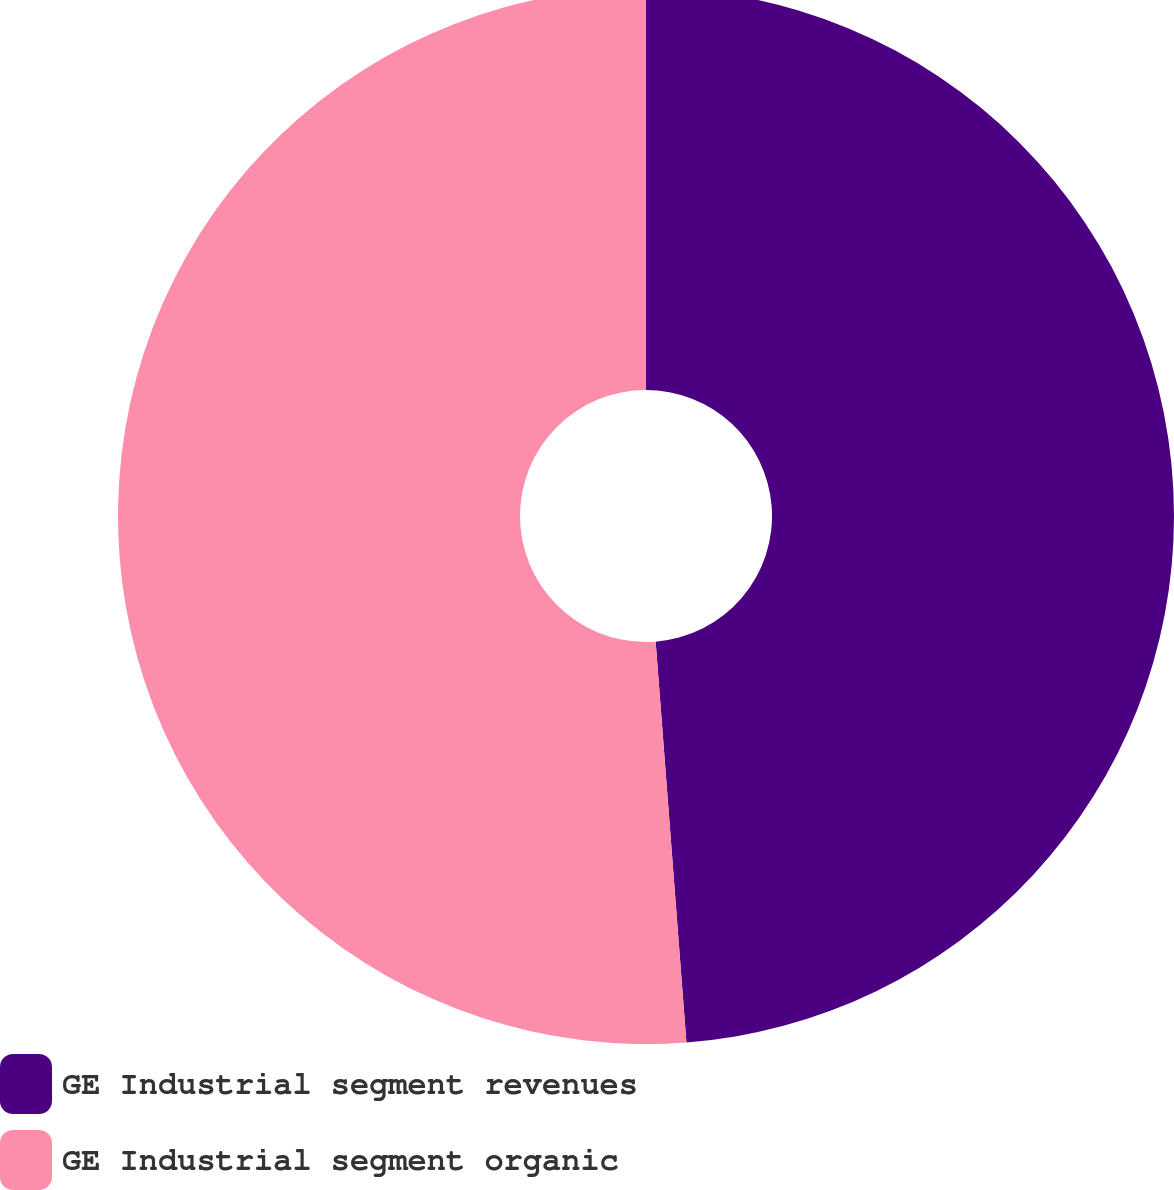Convert chart to OTSL. <chart><loc_0><loc_0><loc_500><loc_500><pie_chart><fcel>GE Industrial segment revenues<fcel>GE Industrial segment organic<nl><fcel>48.78%<fcel>51.22%<nl></chart> 